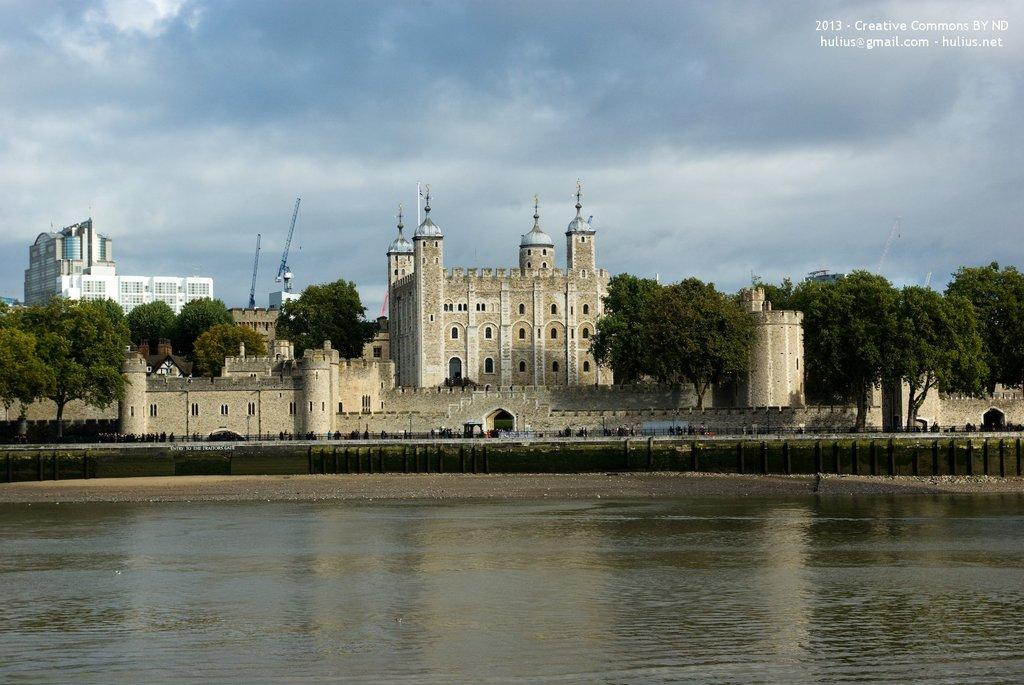What type of structures can be seen in the image? There are buildings in the image. What other natural elements are present in the image? There are trees and water visible in the image. What can be seen in the background of the image? The sky is visible in the background of the image. What is the condition of the sky in the image? There are clouds in the sky. What type of fruit can be seen growing on the buildings in the image? There is no fruit visible on the buildings in the image. How many pigs are present in the image? There are no pigs present in the image. 